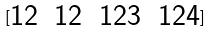Convert formula to latex. <formula><loc_0><loc_0><loc_500><loc_500>[ \begin{matrix} 1 2 & 1 2 & 1 2 3 & 1 2 4 \\ \end{matrix} ]</formula> 